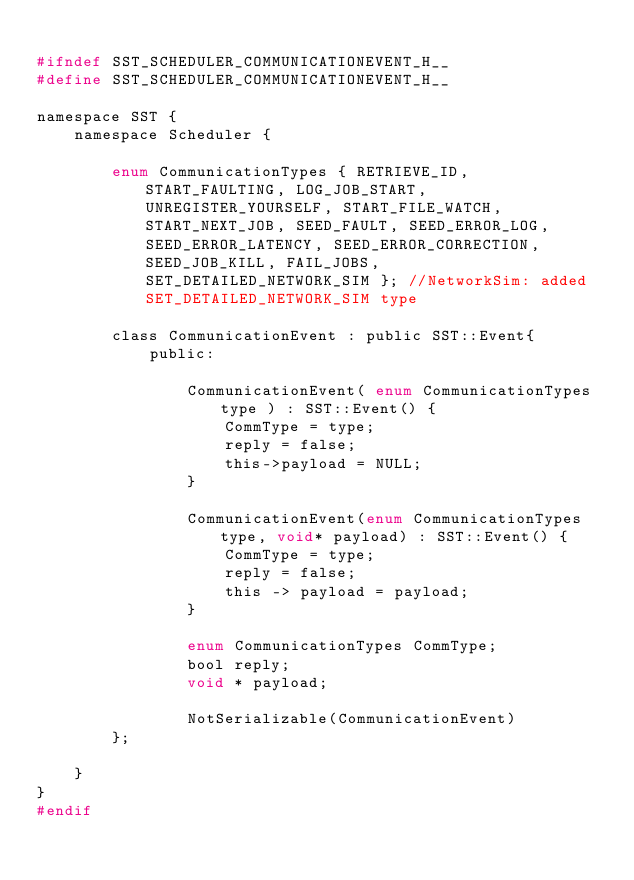Convert code to text. <code><loc_0><loc_0><loc_500><loc_500><_C_>
#ifndef SST_SCHEDULER_COMMUNICATIONEVENT_H__
#define SST_SCHEDULER_COMMUNICATIONEVENT_H__

namespace SST {
    namespace Scheduler {

        enum CommunicationTypes { RETRIEVE_ID, START_FAULTING, LOG_JOB_START, UNREGISTER_YOURSELF, START_FILE_WATCH, START_NEXT_JOB, SEED_FAULT, SEED_ERROR_LOG, SEED_ERROR_LATENCY, SEED_ERROR_CORRECTION, SEED_JOB_KILL, FAIL_JOBS, SET_DETAILED_NETWORK_SIM }; //NetworkSim: added SET_DETAILED_NETWORK_SIM type

        class CommunicationEvent : public SST::Event{
            public:

                CommunicationEvent( enum CommunicationTypes type ) : SST::Event() {
                    CommType = type;
                    reply = false;
                    this->payload = NULL;
                }

                CommunicationEvent(enum CommunicationTypes type, void* payload) : SST::Event() {
                    CommType = type;
                    reply = false;
                    this -> payload = payload;
                }

                enum CommunicationTypes CommType;
                bool reply;
                void * payload;
                
                NotSerializable(CommunicationEvent)
        };

    }
}
#endif

</code> 